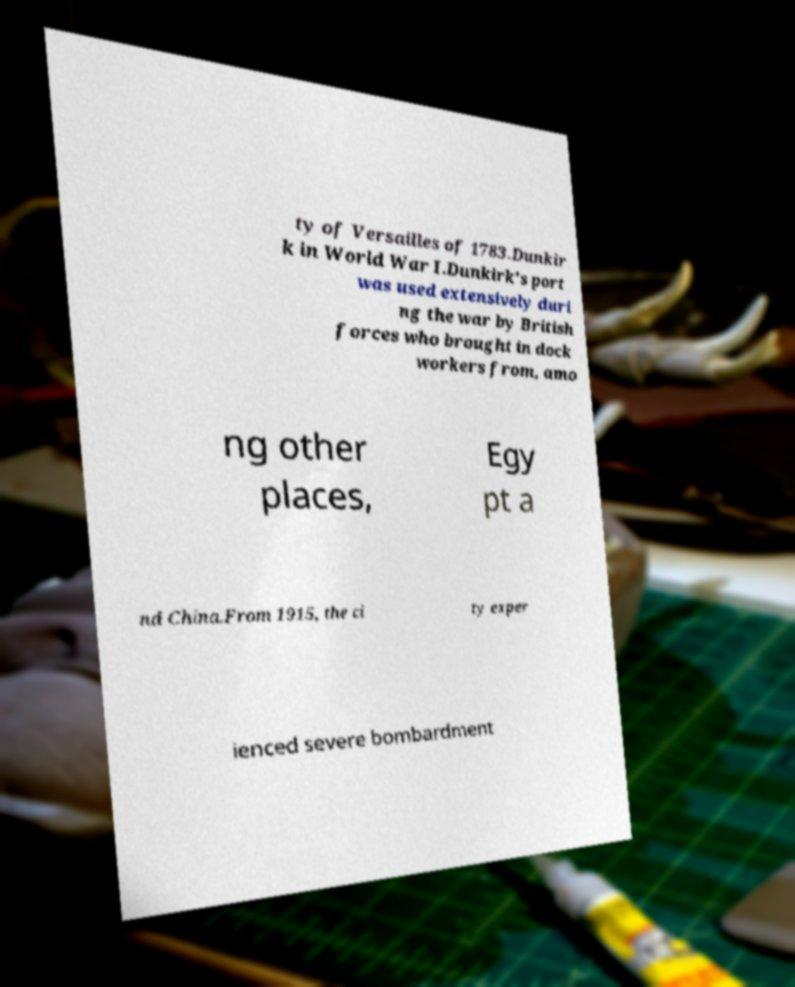Please read and relay the text visible in this image. What does it say? ty of Versailles of 1783.Dunkir k in World War I.Dunkirk's port was used extensively duri ng the war by British forces who brought in dock workers from, amo ng other places, Egy pt a nd China.From 1915, the ci ty exper ienced severe bombardment 